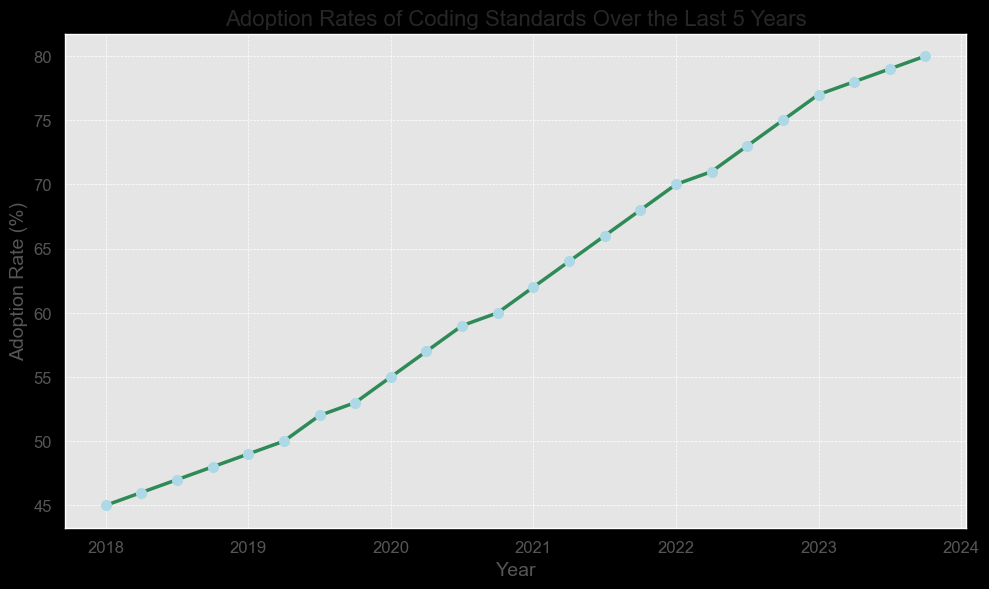Which year experienced the steepest increase in adoption rate? To determine the steepest increase, we should look for the largest change in the adoption rate from one year to the next. The biggest increase occurs between 2019 and 2020 (i.e., from 53% to 55%).
Answer: 2020 What was the average adoption rate from 2021 to 2023? We calculate the average by summing the adoption rates between these years and dividing by the number of data points. (62 + 64 + 66 + 68 + 70 + 71 + 73 + 75 + 77 + 78 + 79 + 80) / 12 = 72.25%
Answer: 72.25% Did the adoption rate ever decrease from one quarter to the next? We analyze the adoption rates and find that they consistently increase in each quarter over the entire time period.
Answer: No What was the adoption rate at the end of 2022? We need to find the adoption rate corresponding to the end of 2022, which is 2022.75. The adoption rate at this point is 75%.
Answer: 75% By how many percentage points did the adoption rate increase from 2018 to 2023? We find the adoption rates at the start of 2018 (45%) and the end of 2023 (80%) and subtract the former from the latter: 80% - 45% = 35%.
Answer: 35 Which year appears to have the highest adoption rate at its end? We look at the adoption rates at the ends of each year (2018.75, 2019.75, etc.). The highest rate is at the end of 2023 (80%).
Answer: 2023 How does the adoption rate in mid-2018 compare to mid-2020? We compare the adoption rates at 2018.5 (47%) and 2020.5 (59%). The rate is higher in mid-2020.
Answer: Higher What is the color of the line representing the adoption rate trend? By referring to the visual attributes in the figure's description, the line is colored green.
Answer: Green What's the difference in adoption rates between 2019.5 and 2021.5? We subtract the adoption rate at 2019.5 (52%) from the rate at 2021.5 (66%): 66% - 52% = 14%.
Answer: 14 Which year had the adoption rate closest to 70%? We check the adoption rate plotted against each year. It hits 70% exactly at the start of 2022.
Answer: 2022 